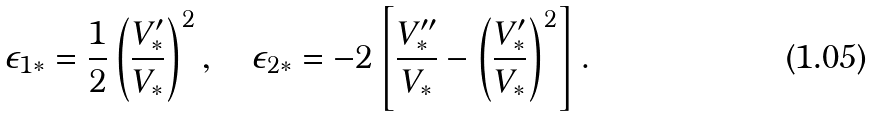Convert formula to latex. <formula><loc_0><loc_0><loc_500><loc_500>\epsilon _ { 1 * } = \frac { 1 } { 2 } \left ( \frac { V _ { * } ^ { \prime } } { V _ { * } } \right ) ^ { 2 } , \quad \epsilon _ { 2 * } = - 2 \left [ \frac { V _ { * } ^ { \prime \prime } } { V _ { * } } - \left ( \frac { V _ { * } ^ { \prime } } { V _ { * } } \right ) ^ { 2 } \right ] .</formula> 